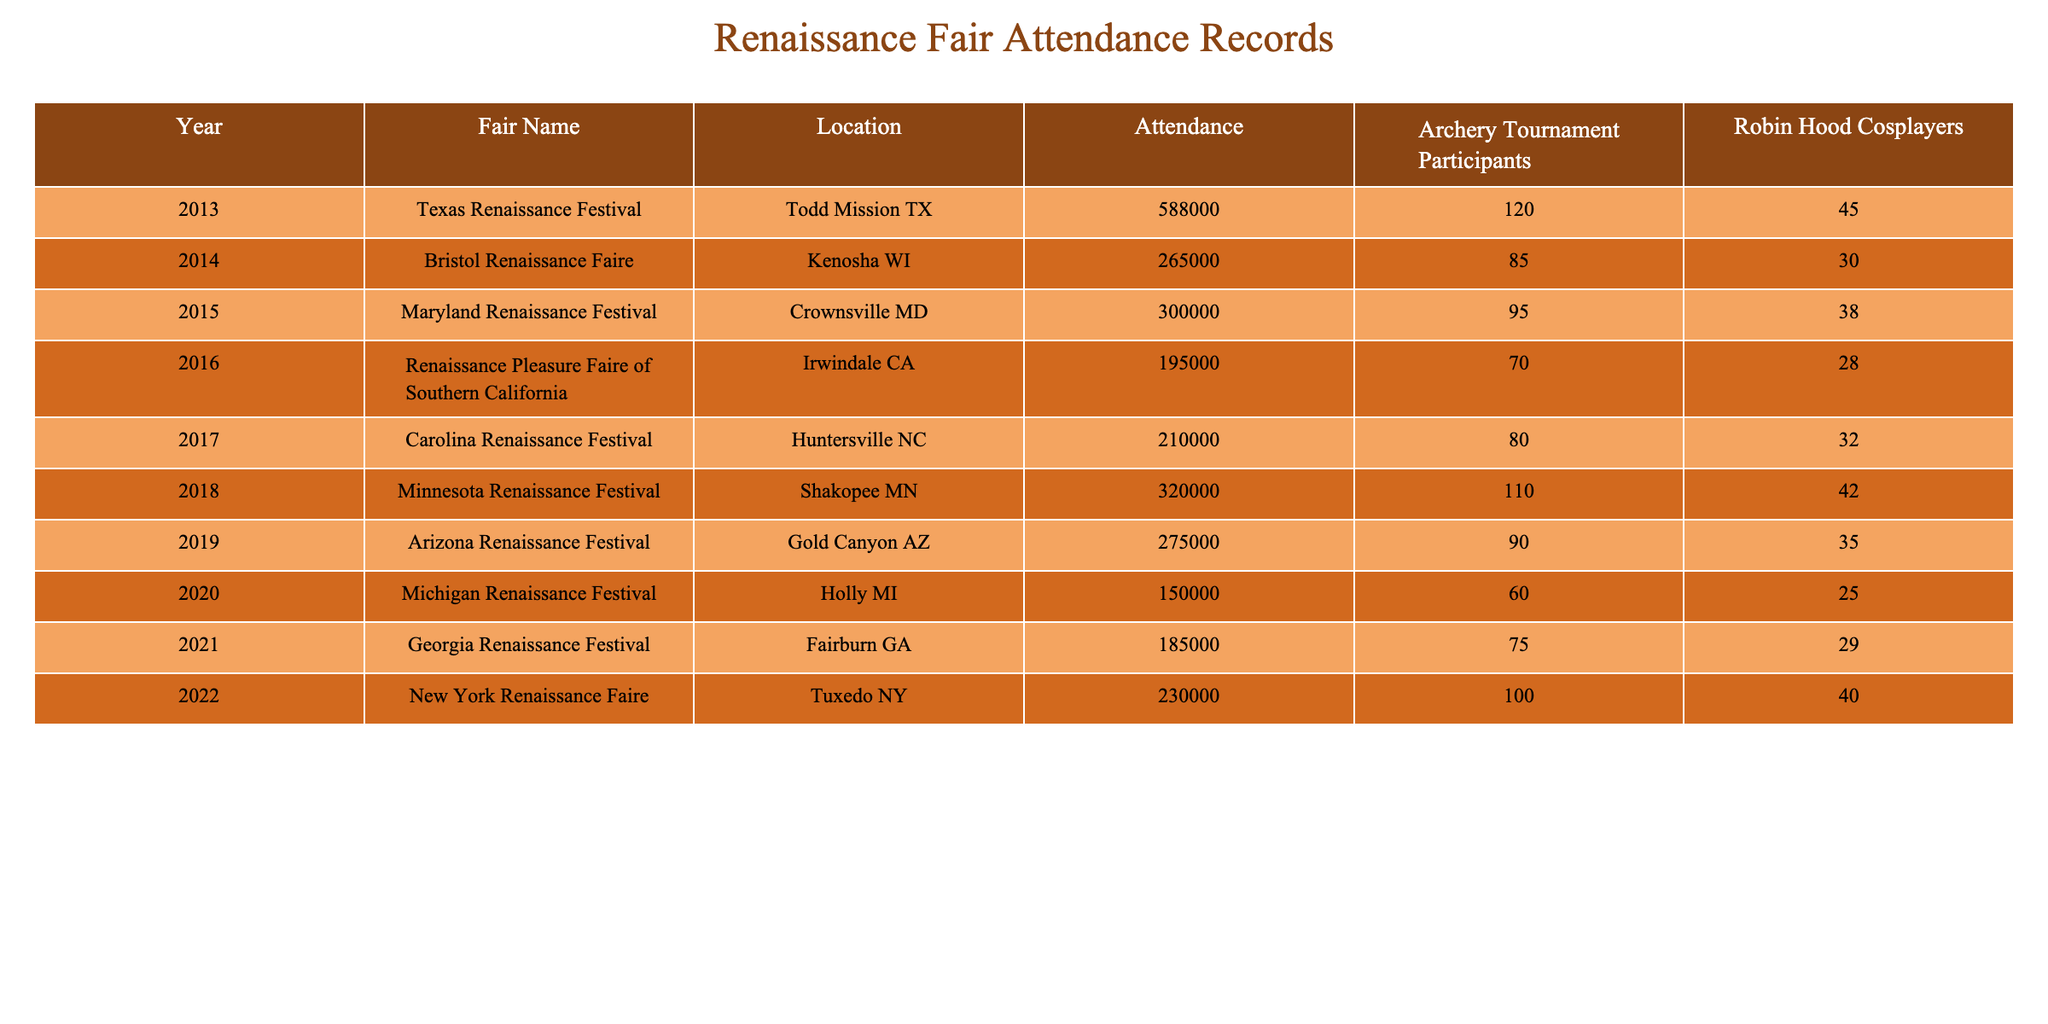What was the attendance at the Texas Renaissance Festival in 2013? The table shows that the attendance at the Texas Renaissance Festival in 2013 is listed as 588,000.
Answer: 588,000 How many Robin Hood cosplayers were there at the Minnesota Renaissance Festival in 2018? Referring to the table, the Minnesota Renaissance Festival in 2018 reported 42 Robin Hood cosplayers.
Answer: 42 What is the average attendance of the fairs held between 2015 and 2022? First, sum the attendance values from those years: (300000 + 195000 + 210000 + 320000 + 275000 + 150000 + 185000 + 230000) = 1,865,000. Then, divide by 8 (the number of years) to find the average: 1,865,000 / 8 = 233,125.
Answer: 233,125 Which fair had the highest attendance and what was that number? The table indicates that the Texas Renaissance Festival in 2013 had the highest attendance at 588,000.
Answer: 588,000 How many archery tournament participants were there at the Georgia Renaissance Festival in 2021? According to the table, the Georgia Renaissance Festival in 2021 had 75 participants in the archery tournament.
Answer: 75 Which year had the lowest attendance, and what was the attendance figure? By examining the table, the Michigan Renaissance Festival in 2020 had the lowest attendance at 150,000.
Answer: 150,000 How many more Robin Hood cosplayers were there at the Texas Renaissance Festival in 2013 compared to the Maryland Renaissance Festival in 2015? Texas Renaissance Festival had 45 cosplayers in 2013 and Maryland Renaissance Festival had 38 cosplayers in 2015. The difference is 45 - 38 = 7 more cosplayers at Texas's fair.
Answer: 7 What was the total number of archery tournament participants from 2013 to 2019? Add the archery participants from 2013 to 2019: 120 + 85 + 95 + 70 + 80 + 90 = 540.
Answer: 540 Was the attendance at the Arizona Renaissance Festival in 2019 greater than 300,000? The table shows that the attendance at the Arizona Renaissance Festival in 2019 was 275,000, which is less than 300,000. Therefore, the statement is false.
Answer: No In which year did the Minnesota Renaissance Festival have more archery participants than the Georgia Renaissance Festival? The Minnesota Renaissance Festival in 2018 had 110 archery participants and the Georgia Renaissance Festival in 2021 had 75 participants. Thus, 2018 had more participants.
Answer: 2018 